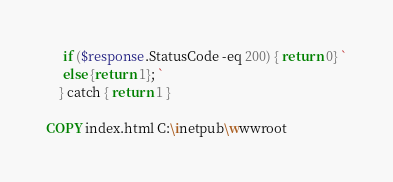<code> <loc_0><loc_0><loc_500><loc_500><_Dockerfile_>     if ($response.StatusCode -eq 200) { return 0} `
     else {return 1}; `
    } catch { return 1 }

COPY index.html C:\inetpub\wwwroot</code> 